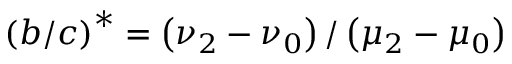<formula> <loc_0><loc_0><loc_500><loc_500>\left ( b / c \right ) ^ { \ast } = \left ( \nu _ { 2 } - \nu _ { 0 } \right ) / \left ( \mu _ { 2 } - \mu _ { 0 } \right )</formula> 